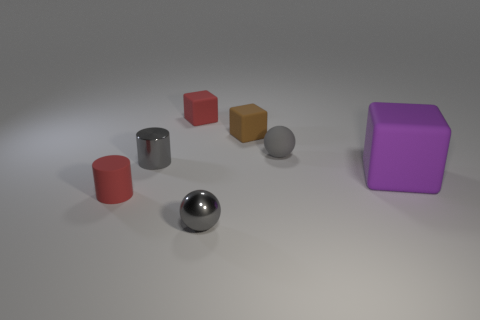Subtract all red blocks. How many blocks are left? 2 Subtract all blocks. How many objects are left? 4 Subtract all purple matte things. Subtract all metallic balls. How many objects are left? 5 Add 6 purple rubber things. How many purple rubber things are left? 7 Add 5 tiny red rubber cylinders. How many tiny red rubber cylinders exist? 6 Add 2 big cyan metal balls. How many objects exist? 9 Subtract all brown cubes. How many cubes are left? 2 Subtract 0 blue spheres. How many objects are left? 7 Subtract 2 cylinders. How many cylinders are left? 0 Subtract all brown cubes. Subtract all purple balls. How many cubes are left? 2 